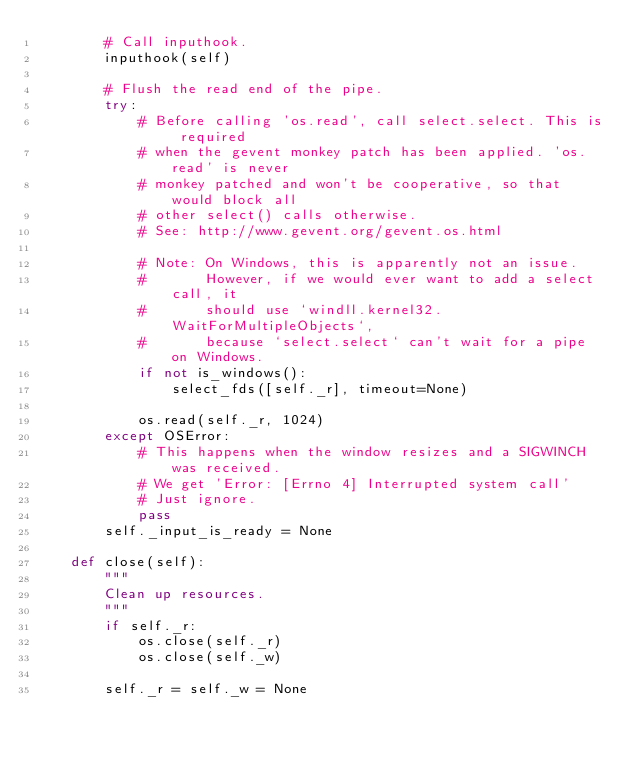<code> <loc_0><loc_0><loc_500><loc_500><_Python_>        # Call inputhook.
        inputhook(self)

        # Flush the read end of the pipe.
        try:
            # Before calling 'os.read', call select.select. This is required
            # when the gevent monkey patch has been applied. 'os.read' is never
            # monkey patched and won't be cooperative, so that would block all
            # other select() calls otherwise.
            # See: http://www.gevent.org/gevent.os.html

            # Note: On Windows, this is apparently not an issue.
            #       However, if we would ever want to add a select call, it
            #       should use `windll.kernel32.WaitForMultipleObjects`,
            #       because `select.select` can't wait for a pipe on Windows.
            if not is_windows():
                select_fds([self._r], timeout=None)

            os.read(self._r, 1024)
        except OSError:
            # This happens when the window resizes and a SIGWINCH was received.
            # We get 'Error: [Errno 4] Interrupted system call'
            # Just ignore.
            pass
        self._input_is_ready = None

    def close(self):
        """
        Clean up resources.
        """
        if self._r:
            os.close(self._r)
            os.close(self._w)

        self._r = self._w = None
</code> 